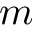<formula> <loc_0><loc_0><loc_500><loc_500>m</formula> 